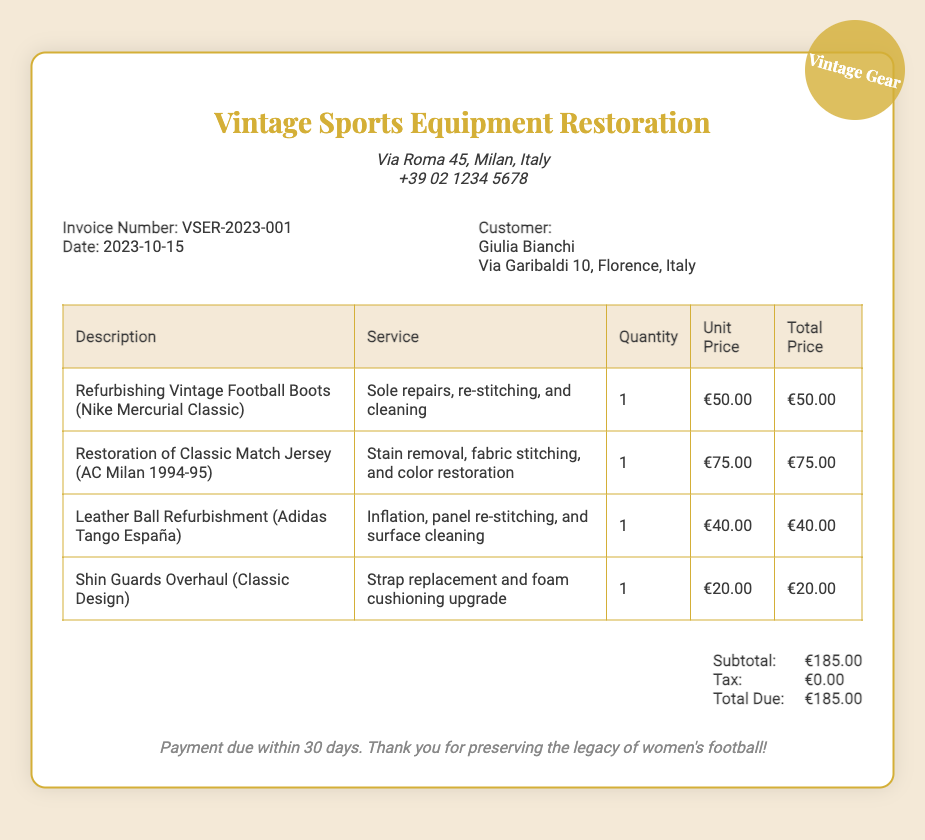What is the invoice number? The invoice number is provided in the document for identification purposes.
Answer: VSER-2023-001 Who is the customer? The document lists the name and details of the customer receiving the invoice.
Answer: Giulia Bianchi What is the date of the invoice? The date indicates when the invoice was created and is important for payment tracking.
Answer: 2023-10-15 What is the total due amount? The total due shows how much the customer must pay after all services rendered are calculated.
Answer: €185.00 How many services were listed in the bill? The number of services indicates how many different refurbishing tasks were carried out.
Answer: 4 What type of football boots were refurbished? This question looks for specific information about the item serviced.
Answer: Nike Mercurial Classic What service was provided for the classic match jersey? Examining the service gives insight into the restoration efforts made for the item.
Answer: Stain removal, fabric stitching, and color restoration What is the tax amount shown on the bill? The tax amount is relevant for understanding the total costs reflected in the bill.
Answer: €0.00 How long does the customer have to make the payment? This indicates the payment terms laid out in the document and ensures clarity on due dates.
Answer: 30 days 